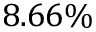Convert formula to latex. <formula><loc_0><loc_0><loc_500><loc_500>8 . 6 6 \%</formula> 